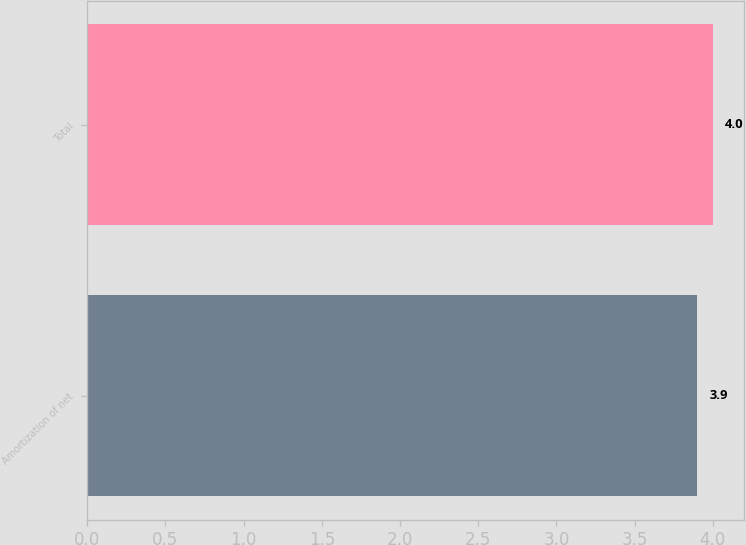Convert chart. <chart><loc_0><loc_0><loc_500><loc_500><bar_chart><fcel>Amortization of net<fcel>Total<nl><fcel>3.9<fcel>4<nl></chart> 